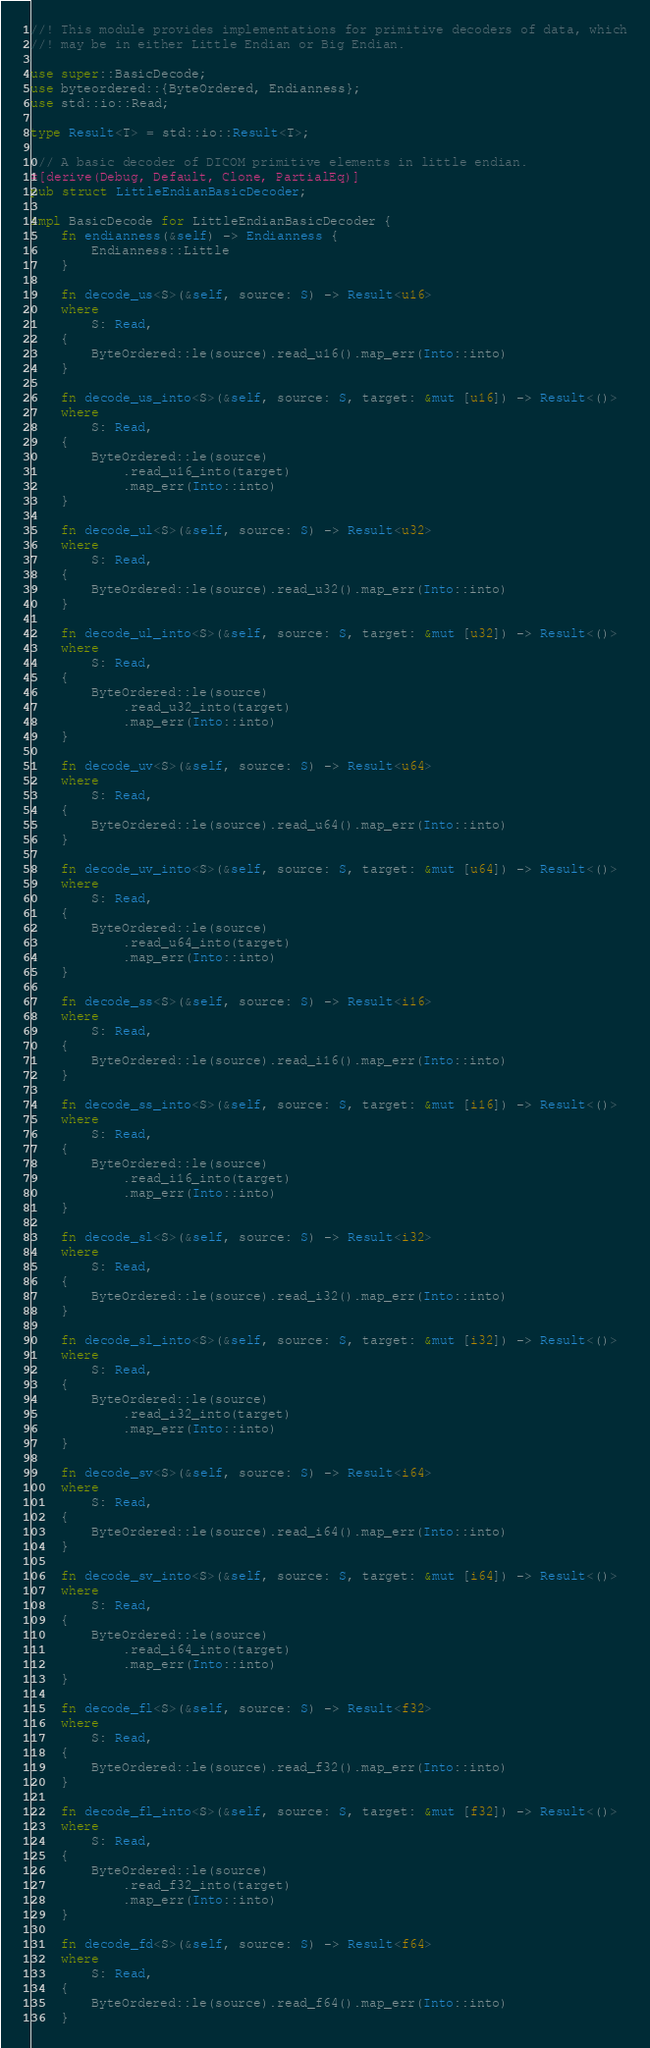Convert code to text. <code><loc_0><loc_0><loc_500><loc_500><_Rust_>//! This module provides implementations for primitive decoders of data, which
//! may be in either Little Endian or Big Endian.

use super::BasicDecode;
use byteordered::{ByteOrdered, Endianness};
use std::io::Read;

type Result<T> = std::io::Result<T>;

/// A basic decoder of DICOM primitive elements in little endian.
#[derive(Debug, Default, Clone, PartialEq)]
pub struct LittleEndianBasicDecoder;

impl BasicDecode for LittleEndianBasicDecoder {
    fn endianness(&self) -> Endianness {
        Endianness::Little
    }

    fn decode_us<S>(&self, source: S) -> Result<u16>
    where
        S: Read,
    {
        ByteOrdered::le(source).read_u16().map_err(Into::into)
    }

    fn decode_us_into<S>(&self, source: S, target: &mut [u16]) -> Result<()>
    where
        S: Read,
    {
        ByteOrdered::le(source)
            .read_u16_into(target)
            .map_err(Into::into)
    }

    fn decode_ul<S>(&self, source: S) -> Result<u32>
    where
        S: Read,
    {
        ByteOrdered::le(source).read_u32().map_err(Into::into)
    }

    fn decode_ul_into<S>(&self, source: S, target: &mut [u32]) -> Result<()>
    where
        S: Read,
    {
        ByteOrdered::le(source)
            .read_u32_into(target)
            .map_err(Into::into)
    }

    fn decode_uv<S>(&self, source: S) -> Result<u64>
    where
        S: Read,
    {
        ByteOrdered::le(source).read_u64().map_err(Into::into)
    }

    fn decode_uv_into<S>(&self, source: S, target: &mut [u64]) -> Result<()>
    where
        S: Read,
    {
        ByteOrdered::le(source)
            .read_u64_into(target)
            .map_err(Into::into)
    }

    fn decode_ss<S>(&self, source: S) -> Result<i16>
    where
        S: Read,
    {
        ByteOrdered::le(source).read_i16().map_err(Into::into)
    }

    fn decode_ss_into<S>(&self, source: S, target: &mut [i16]) -> Result<()>
    where
        S: Read,
    {
        ByteOrdered::le(source)
            .read_i16_into(target)
            .map_err(Into::into)
    }

    fn decode_sl<S>(&self, source: S) -> Result<i32>
    where
        S: Read,
    {
        ByteOrdered::le(source).read_i32().map_err(Into::into)
    }

    fn decode_sl_into<S>(&self, source: S, target: &mut [i32]) -> Result<()>
    where
        S: Read,
    {
        ByteOrdered::le(source)
            .read_i32_into(target)
            .map_err(Into::into)
    }

    fn decode_sv<S>(&self, source: S) -> Result<i64>
    where
        S: Read,
    {
        ByteOrdered::le(source).read_i64().map_err(Into::into)
    }

    fn decode_sv_into<S>(&self, source: S, target: &mut [i64]) -> Result<()>
    where
        S: Read,
    {
        ByteOrdered::le(source)
            .read_i64_into(target)
            .map_err(Into::into)
    }

    fn decode_fl<S>(&self, source: S) -> Result<f32>
    where
        S: Read,
    {
        ByteOrdered::le(source).read_f32().map_err(Into::into)
    }

    fn decode_fl_into<S>(&self, source: S, target: &mut [f32]) -> Result<()>
    where
        S: Read,
    {
        ByteOrdered::le(source)
            .read_f32_into(target)
            .map_err(Into::into)
    }

    fn decode_fd<S>(&self, source: S) -> Result<f64>
    where
        S: Read,
    {
        ByteOrdered::le(source).read_f64().map_err(Into::into)
    }
</code> 